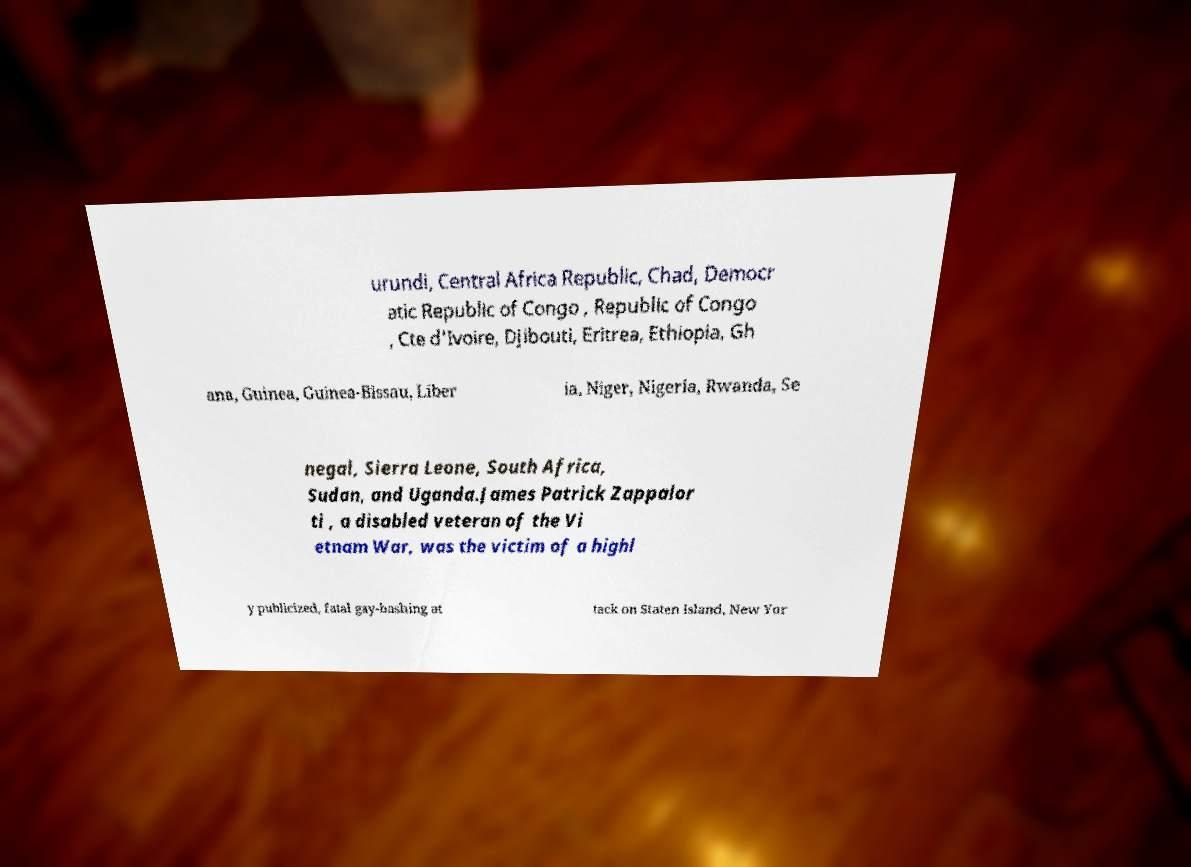For documentation purposes, I need the text within this image transcribed. Could you provide that? urundi, Central Africa Republic, Chad, Democr atic Republic of Congo , Republic of Congo , Cte d'Ivoire, Djibouti, Eritrea, Ethiopia, Gh ana, Guinea, Guinea-Bissau, Liber ia, Niger, Nigeria, Rwanda, Se negal, Sierra Leone, South Africa, Sudan, and Uganda.James Patrick Zappalor ti , a disabled veteran of the Vi etnam War, was the victim of a highl y publicized, fatal gay-bashing at tack on Staten Island, New Yor 